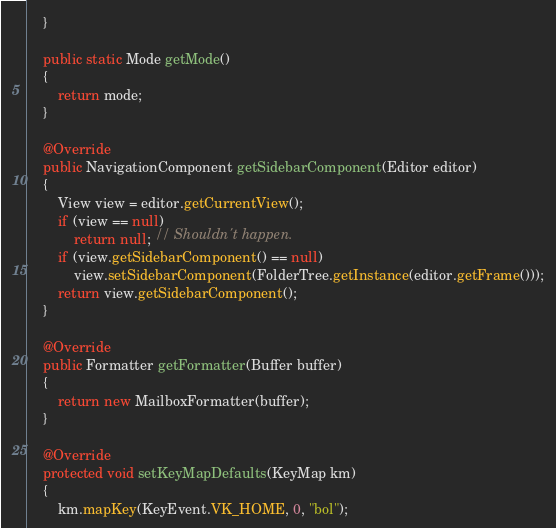Convert code to text. <code><loc_0><loc_0><loc_500><loc_500><_Java_>    }

    public static Mode getMode()
    {
        return mode;
    }

    @Override
	public NavigationComponent getSidebarComponent(Editor editor)
    {
        View view = editor.getCurrentView();
        if (view == null)
            return null; // Shouldn't happen.
        if (view.getSidebarComponent() == null)
            view.setSidebarComponent(FolderTree.getInstance(editor.getFrame()));
        return view.getSidebarComponent();
    }

    @Override
	public Formatter getFormatter(Buffer buffer)
    {
        return new MailboxFormatter(buffer);
    }

    @Override
	protected void setKeyMapDefaults(KeyMap km)
    {
        km.mapKey(KeyEvent.VK_HOME, 0, "bol");</code> 